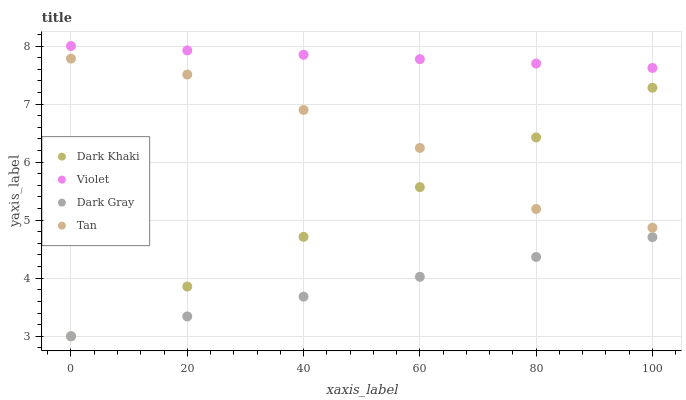Does Dark Gray have the minimum area under the curve?
Answer yes or no. Yes. Does Violet have the maximum area under the curve?
Answer yes or no. Yes. Does Tan have the minimum area under the curve?
Answer yes or no. No. Does Tan have the maximum area under the curve?
Answer yes or no. No. Is Violet the smoothest?
Answer yes or no. Yes. Is Tan the roughest?
Answer yes or no. Yes. Is Dark Gray the smoothest?
Answer yes or no. No. Is Dark Gray the roughest?
Answer yes or no. No. Does Dark Khaki have the lowest value?
Answer yes or no. Yes. Does Tan have the lowest value?
Answer yes or no. No. Does Violet have the highest value?
Answer yes or no. Yes. Does Tan have the highest value?
Answer yes or no. No. Is Tan less than Violet?
Answer yes or no. Yes. Is Violet greater than Tan?
Answer yes or no. Yes. Does Dark Khaki intersect Dark Gray?
Answer yes or no. Yes. Is Dark Khaki less than Dark Gray?
Answer yes or no. No. Is Dark Khaki greater than Dark Gray?
Answer yes or no. No. Does Tan intersect Violet?
Answer yes or no. No. 